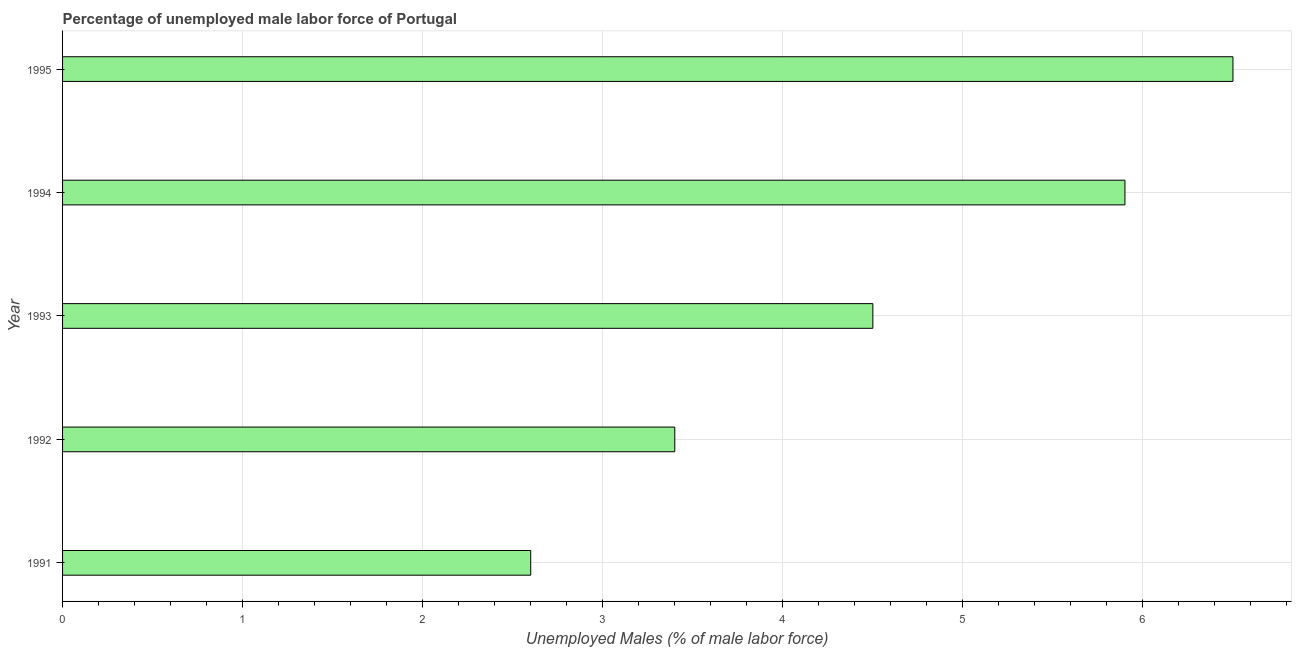Does the graph contain any zero values?
Keep it short and to the point. No. What is the title of the graph?
Ensure brevity in your answer.  Percentage of unemployed male labor force of Portugal. What is the label or title of the X-axis?
Ensure brevity in your answer.  Unemployed Males (% of male labor force). What is the total unemployed male labour force in 1992?
Give a very brief answer. 3.4. Across all years, what is the minimum total unemployed male labour force?
Ensure brevity in your answer.  2.6. In which year was the total unemployed male labour force maximum?
Offer a very short reply. 1995. What is the sum of the total unemployed male labour force?
Offer a very short reply. 22.9. What is the difference between the total unemployed male labour force in 1991 and 1992?
Offer a very short reply. -0.8. What is the average total unemployed male labour force per year?
Provide a succinct answer. 4.58. What is the median total unemployed male labour force?
Provide a short and direct response. 4.5. In how many years, is the total unemployed male labour force greater than 0.2 %?
Keep it short and to the point. 5. What is the ratio of the total unemployed male labour force in 1994 to that in 1995?
Offer a very short reply. 0.91. Is the total unemployed male labour force in 1991 less than that in 1994?
Offer a terse response. Yes. Is the difference between the total unemployed male labour force in 1992 and 1995 greater than the difference between any two years?
Make the answer very short. No. Is the sum of the total unemployed male labour force in 1993 and 1995 greater than the maximum total unemployed male labour force across all years?
Keep it short and to the point. Yes. Are all the bars in the graph horizontal?
Offer a very short reply. Yes. How many years are there in the graph?
Make the answer very short. 5. Are the values on the major ticks of X-axis written in scientific E-notation?
Keep it short and to the point. No. What is the Unemployed Males (% of male labor force) in 1991?
Give a very brief answer. 2.6. What is the Unemployed Males (% of male labor force) in 1992?
Offer a terse response. 3.4. What is the Unemployed Males (% of male labor force) in 1994?
Offer a terse response. 5.9. What is the difference between the Unemployed Males (% of male labor force) in 1991 and 1993?
Your answer should be very brief. -1.9. What is the difference between the Unemployed Males (% of male labor force) in 1991 and 1995?
Give a very brief answer. -3.9. What is the ratio of the Unemployed Males (% of male labor force) in 1991 to that in 1992?
Make the answer very short. 0.77. What is the ratio of the Unemployed Males (% of male labor force) in 1991 to that in 1993?
Your response must be concise. 0.58. What is the ratio of the Unemployed Males (% of male labor force) in 1991 to that in 1994?
Provide a succinct answer. 0.44. What is the ratio of the Unemployed Males (% of male labor force) in 1992 to that in 1993?
Provide a succinct answer. 0.76. What is the ratio of the Unemployed Males (% of male labor force) in 1992 to that in 1994?
Offer a terse response. 0.58. What is the ratio of the Unemployed Males (% of male labor force) in 1992 to that in 1995?
Offer a very short reply. 0.52. What is the ratio of the Unemployed Males (% of male labor force) in 1993 to that in 1994?
Provide a succinct answer. 0.76. What is the ratio of the Unemployed Males (% of male labor force) in 1993 to that in 1995?
Your response must be concise. 0.69. What is the ratio of the Unemployed Males (% of male labor force) in 1994 to that in 1995?
Your answer should be compact. 0.91. 